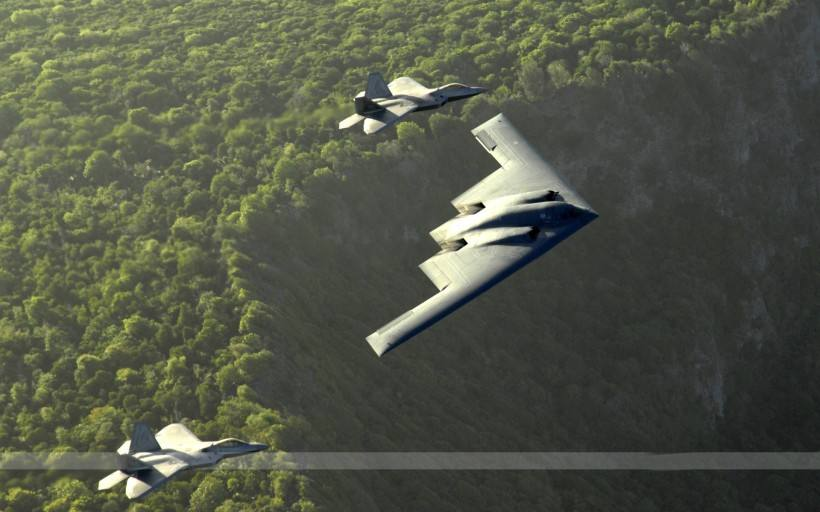How many aeroplanes would there be in the image if one additional aeroplane was added in the scene? Including the one additional aeroplane as mentioned, there would be a total of four aeroplanes in the scene, expanding the current formation and adding to the impressive display of aerial prowess. 